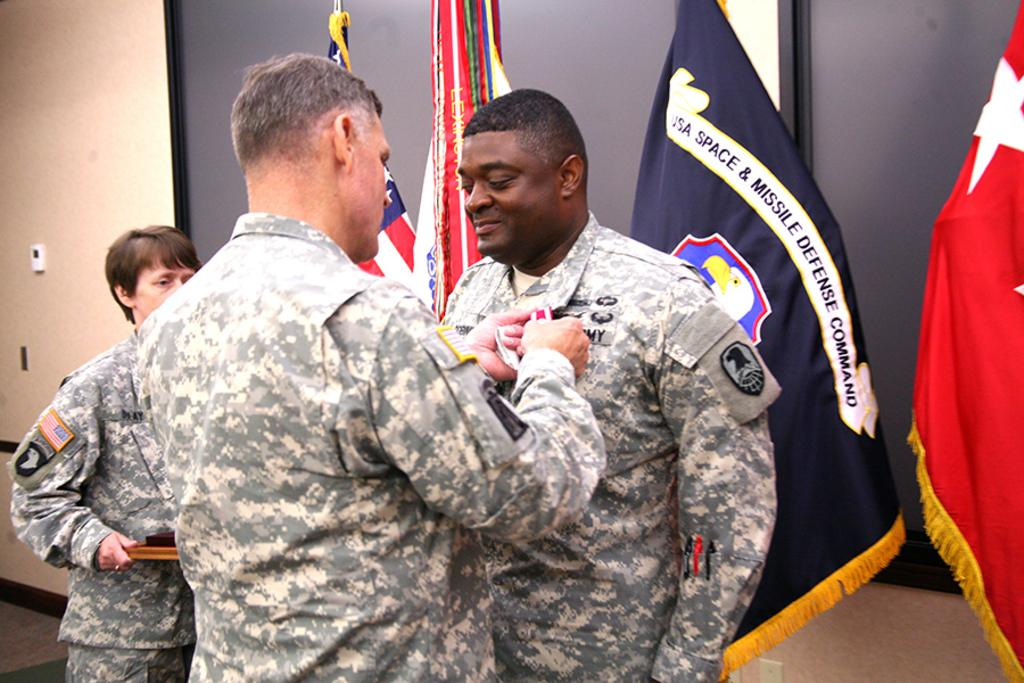Provide a one-sentence caption for the provided image. an army official being sworn in, it seems with a flag behind him that says USA SPACE & MISSLE DEFENSE COMMAND. 